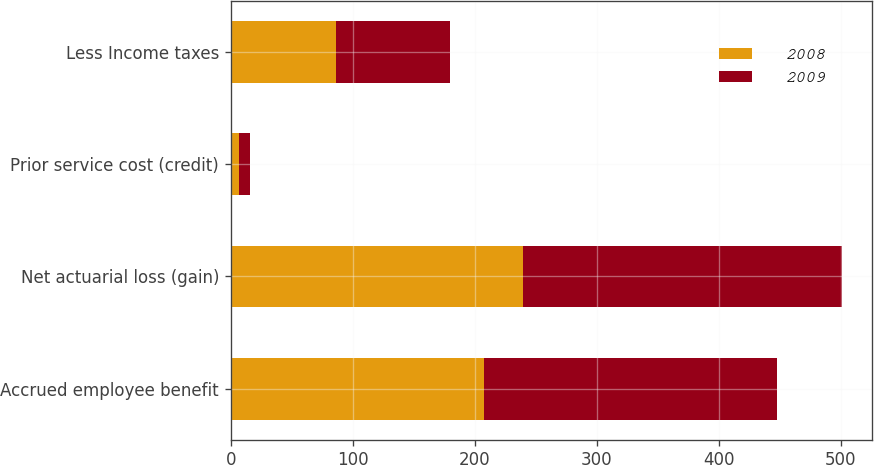Convert chart to OTSL. <chart><loc_0><loc_0><loc_500><loc_500><stacked_bar_chart><ecel><fcel>Accrued employee benefit<fcel>Net actuarial loss (gain)<fcel>Prior service cost (credit)<fcel>Less Income taxes<nl><fcel>2008<fcel>208<fcel>240<fcel>7<fcel>86<nl><fcel>2009<fcel>240<fcel>261<fcel>9<fcel>94<nl></chart> 